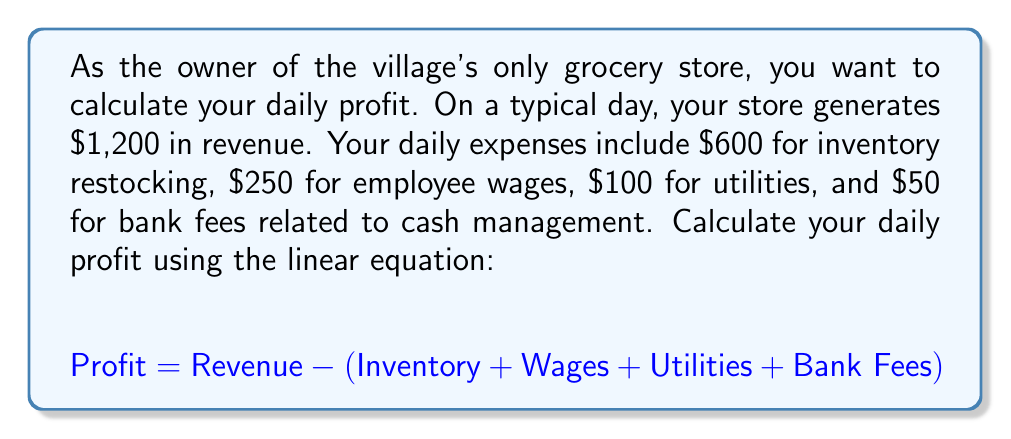Can you answer this question? To solve this problem, we'll use the given linear equation and plug in the values provided:

1. Revenue: $1,200
2. Expenses:
   - Inventory: $600
   - Wages: $250
   - Utilities: $100
   - Bank Fees: $50

Let's substitute these values into the equation:

$$ \begin{align*}
\text{Profit} &= \text{Revenue} - (\text{Inventory} + \text{Wages} + \text{Utilities} + \text{Bank Fees}) \\
&= 1200 - (600 + 250 + 100 + 50) \\
&= 1200 - 1000 \\
&= 200
\end{align*} $$

Therefore, the daily profit is $200.
Answer: $200 